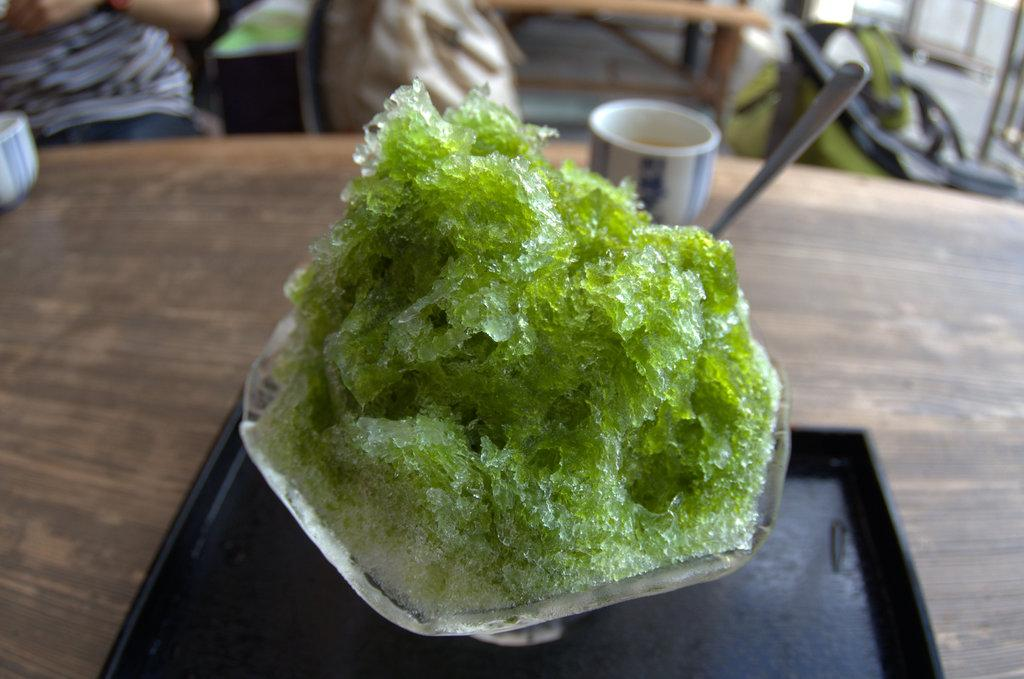What type of dish is prepared with ice in the image? There is a green color dish prepared with ice in the image. How is the dish served? The dish is served in a cup. Where is the cup placed? The cup is placed on a wooden table. Can you describe the background of the image? The background of the image is blurred. Is your aunt visible in the image, blowing smoke from a cloud? No, your aunt is not visible in the image, and there is no smoke or cloud present. 